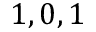Convert formula to latex. <formula><loc_0><loc_0><loc_500><loc_500>1 , 0 , 1</formula> 